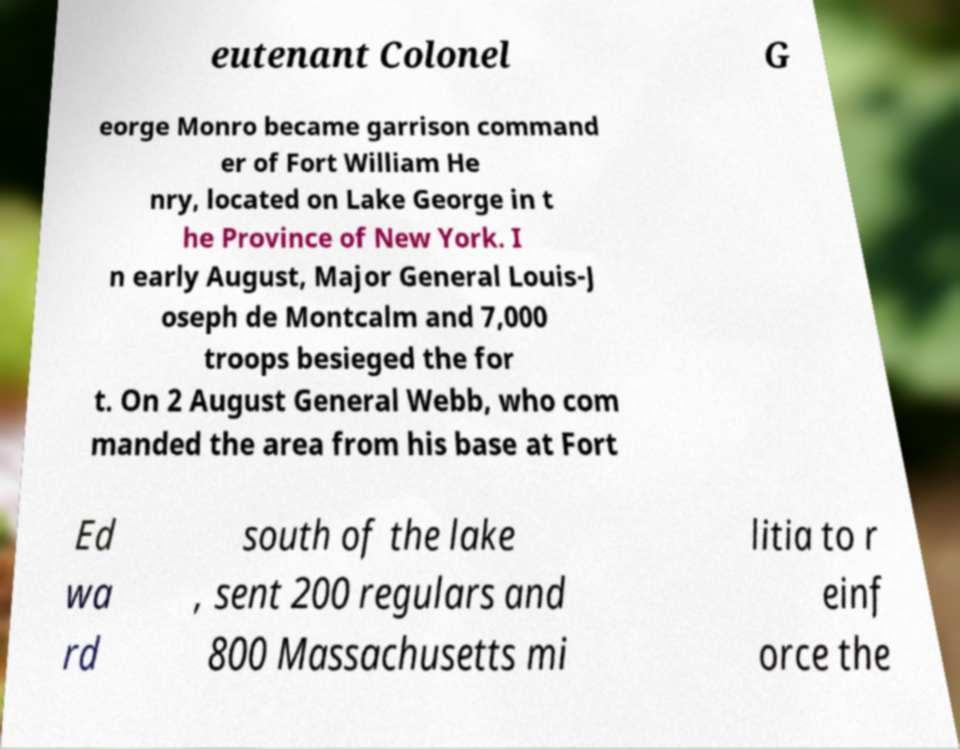Could you assist in decoding the text presented in this image and type it out clearly? eutenant Colonel G eorge Monro became garrison command er of Fort William He nry, located on Lake George in t he Province of New York. I n early August, Major General Louis-J oseph de Montcalm and 7,000 troops besieged the for t. On 2 August General Webb, who com manded the area from his base at Fort Ed wa rd south of the lake , sent 200 regulars and 800 Massachusetts mi litia to r einf orce the 